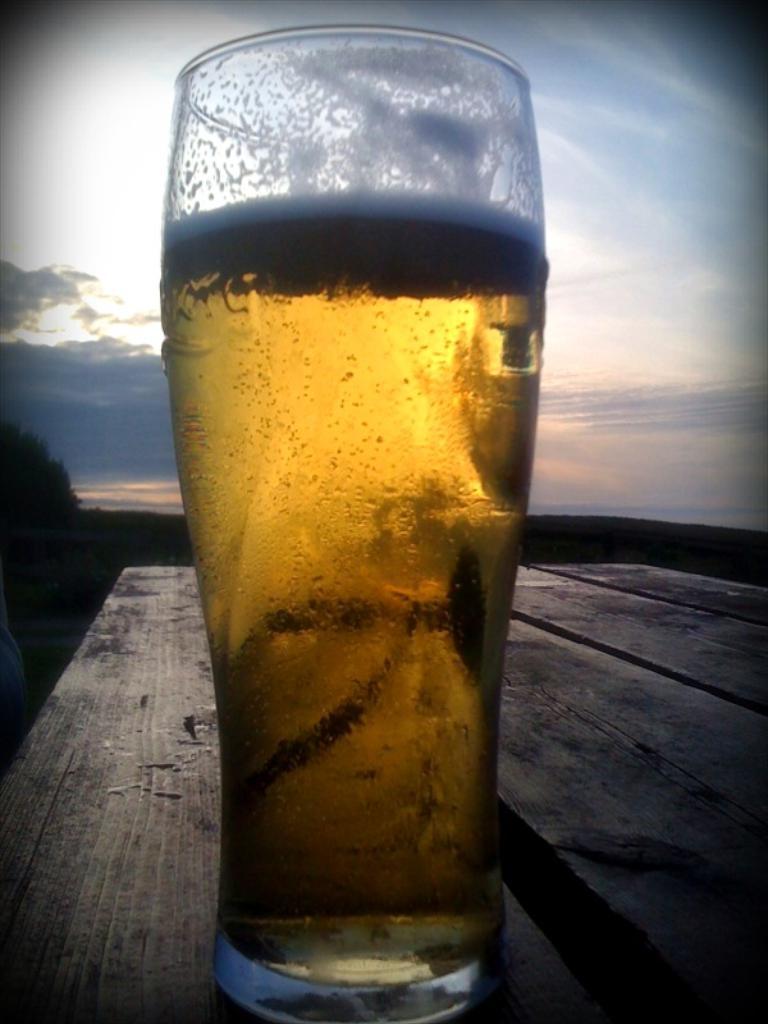How would you summarize this image in a sentence or two? In the middle of the image, there is a glass filled with drink, placed on the wooden table. In the background, there are clouds in the blue sky. 